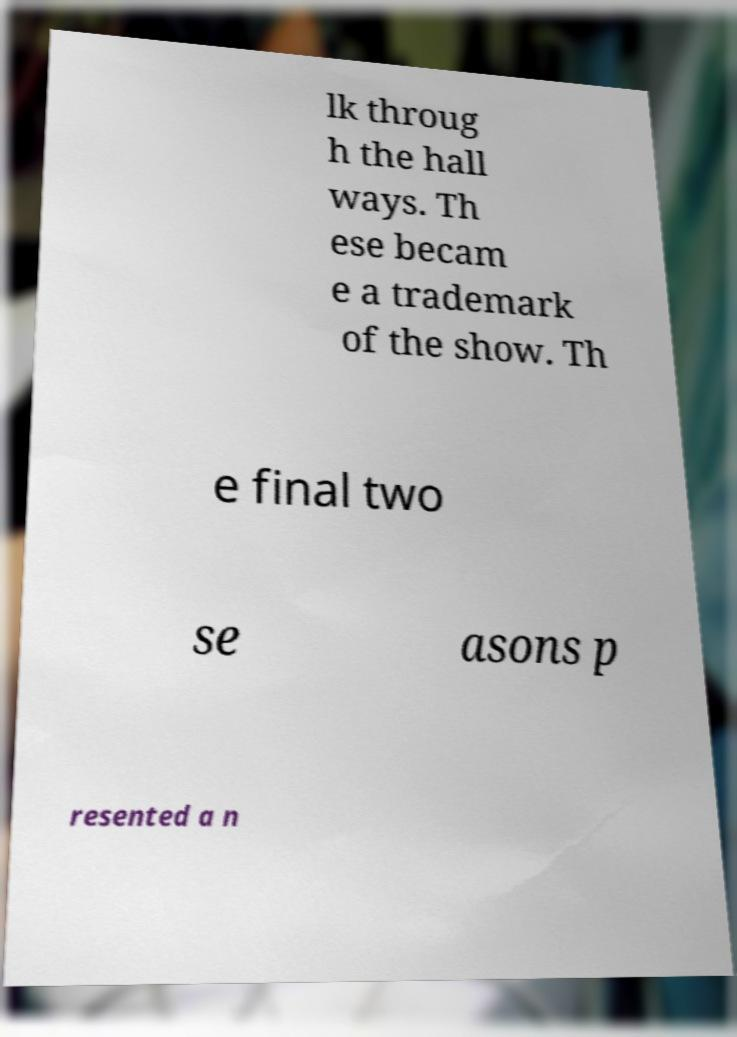I need the written content from this picture converted into text. Can you do that? lk throug h the hall ways. Th ese becam e a trademark of the show. Th e final two se asons p resented a n 